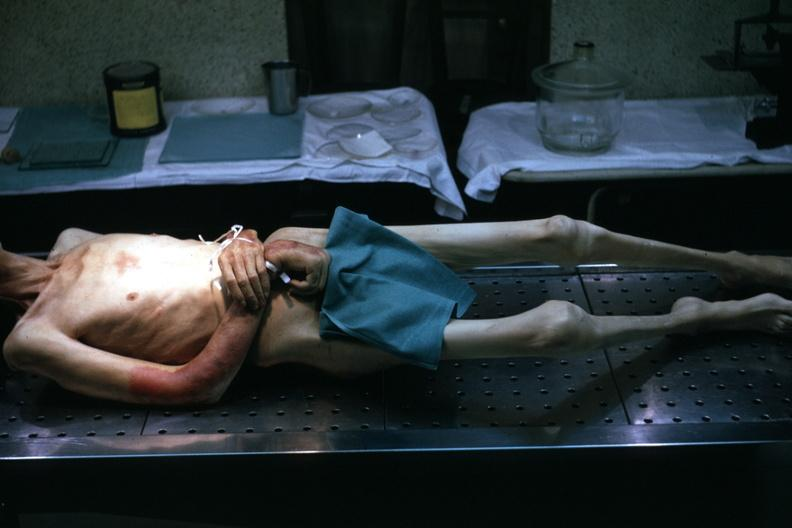s cachexia present?
Answer the question using a single word or phrase. Yes 